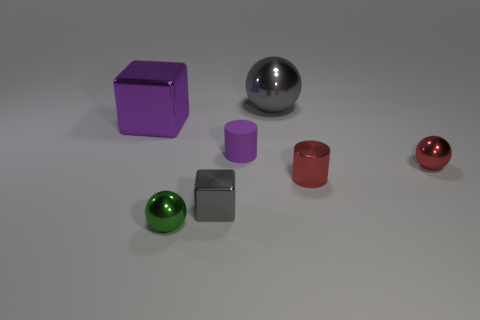How many things are either things behind the small green sphere or gray metallic things that are on the right side of the tiny matte thing? Upon examining the image, I identified 1 small green sphere with 2 items directly behind it: the large purple cube and the small purple cylinder, and to the right of the tiny matte cube, there are 3 metallic gray objects: a large sphere, a medium cylinder, and a small sphere, making a total of 6 items that fit the description given in your question. 